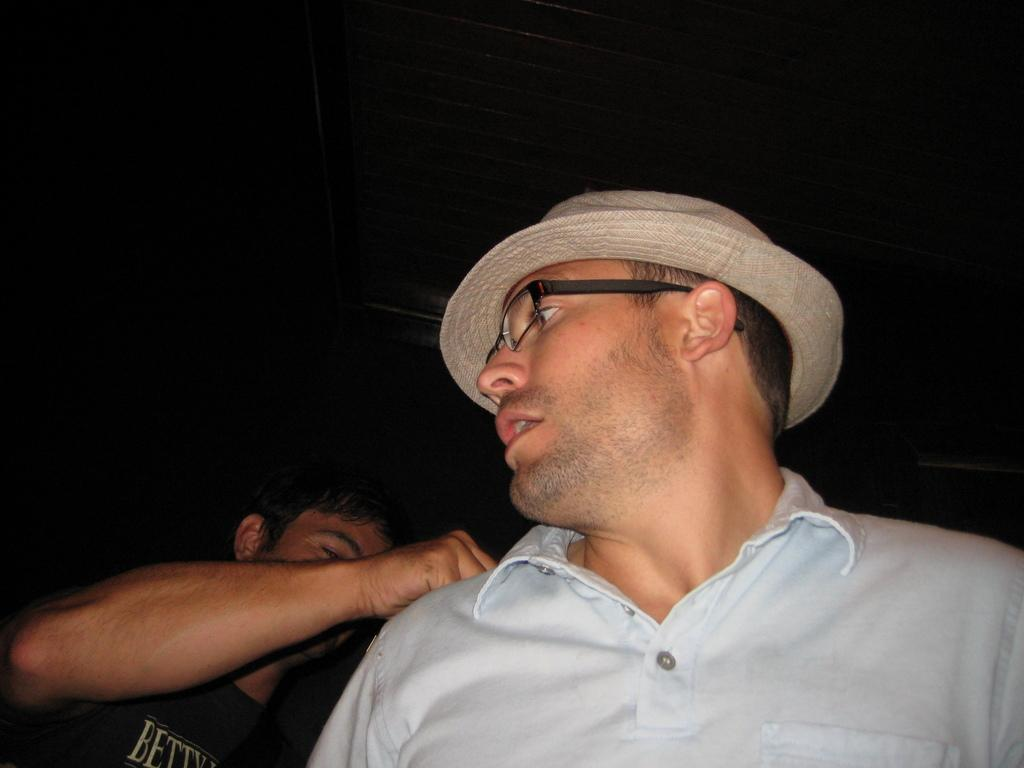What is the person in the image wearing on their face? The person in the image is wearing glasses. What else is the person wearing on their head? The person is also wearing a hat. Can you describe the other person in the image? There is another person on the left side of the image. What color is the background of the image? The background of the image is in black color. What type of wound can be seen on the person's hand in the image? There is no wound visible on the person's hand in the image. What is the occupation of the person wearing the hat in the image? The occupation of the person wearing the hat cannot be determined from the image alone. 